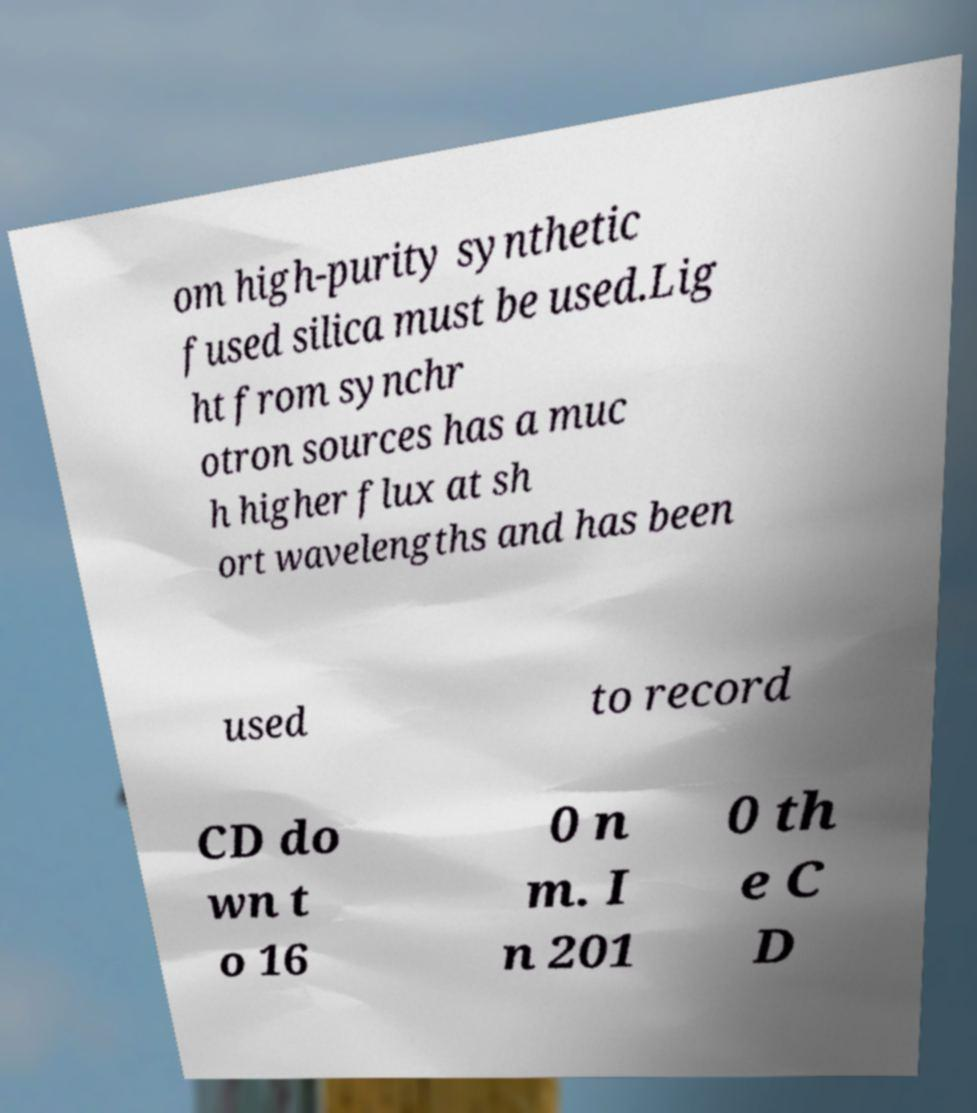What messages or text are displayed in this image? I need them in a readable, typed format. om high-purity synthetic fused silica must be used.Lig ht from synchr otron sources has a muc h higher flux at sh ort wavelengths and has been used to record CD do wn t o 16 0 n m. I n 201 0 th e C D 